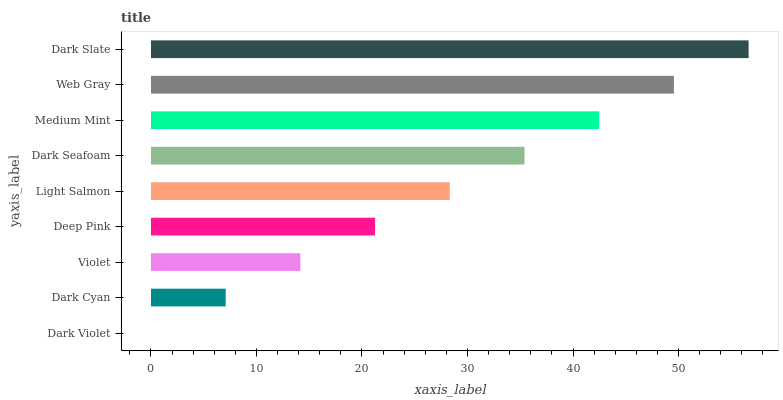Is Dark Violet the minimum?
Answer yes or no. Yes. Is Dark Slate the maximum?
Answer yes or no. Yes. Is Dark Cyan the minimum?
Answer yes or no. No. Is Dark Cyan the maximum?
Answer yes or no. No. Is Dark Cyan greater than Dark Violet?
Answer yes or no. Yes. Is Dark Violet less than Dark Cyan?
Answer yes or no. Yes. Is Dark Violet greater than Dark Cyan?
Answer yes or no. No. Is Dark Cyan less than Dark Violet?
Answer yes or no. No. Is Light Salmon the high median?
Answer yes or no. Yes. Is Light Salmon the low median?
Answer yes or no. Yes. Is Web Gray the high median?
Answer yes or no. No. Is Dark Slate the low median?
Answer yes or no. No. 